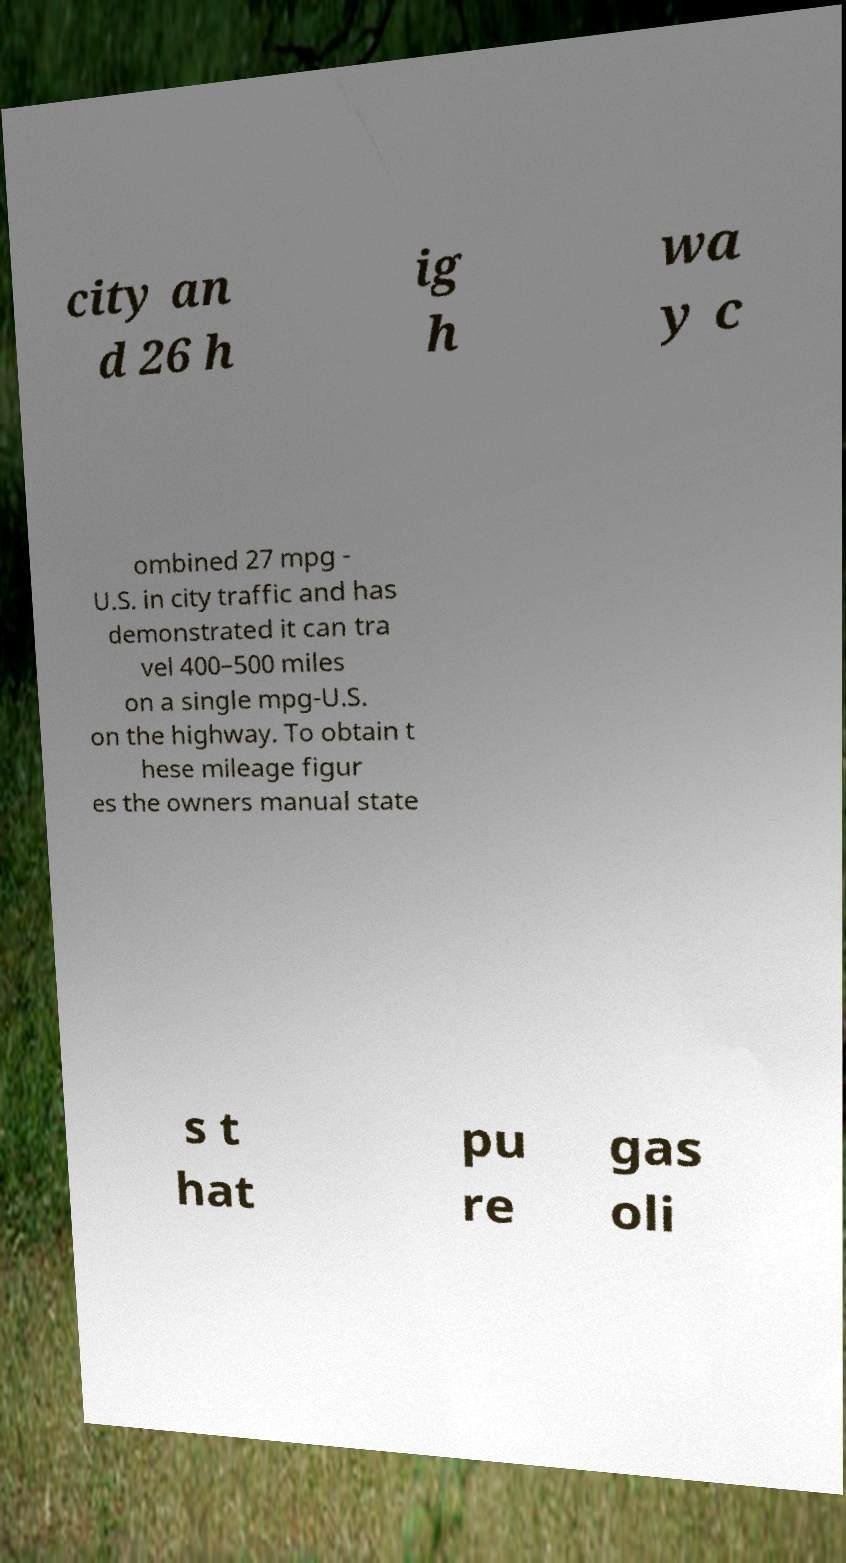Please read and relay the text visible in this image. What does it say? city an d 26 h ig h wa y c ombined 27 mpg - U.S. in city traffic and has demonstrated it can tra vel 400–500 miles on a single mpg-U.S. on the highway. To obtain t hese mileage figur es the owners manual state s t hat pu re gas oli 